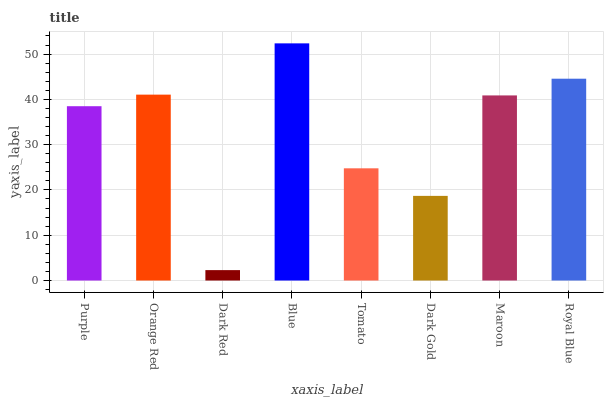Is Orange Red the minimum?
Answer yes or no. No. Is Orange Red the maximum?
Answer yes or no. No. Is Orange Red greater than Purple?
Answer yes or no. Yes. Is Purple less than Orange Red?
Answer yes or no. Yes. Is Purple greater than Orange Red?
Answer yes or no. No. Is Orange Red less than Purple?
Answer yes or no. No. Is Maroon the high median?
Answer yes or no. Yes. Is Purple the low median?
Answer yes or no. Yes. Is Tomato the high median?
Answer yes or no. No. Is Dark Red the low median?
Answer yes or no. No. 